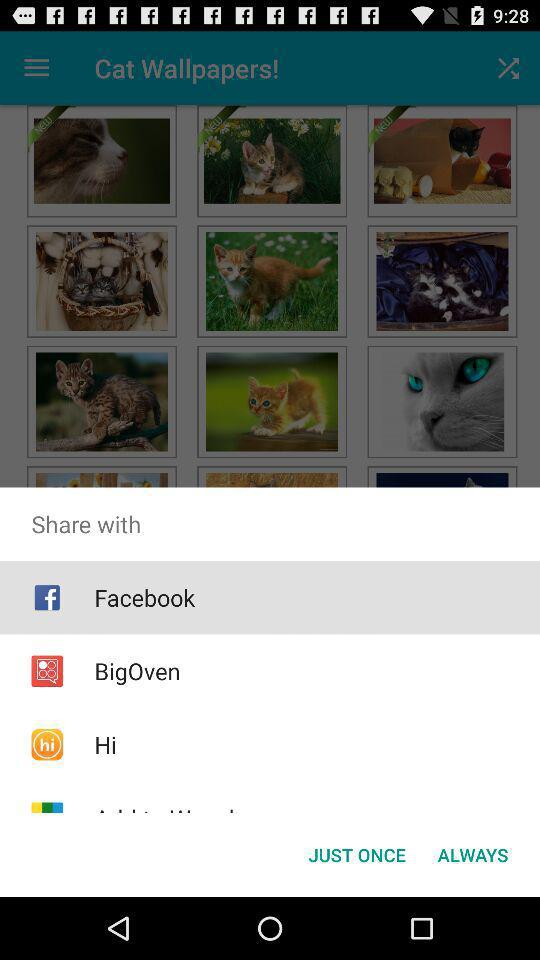Through which applications can the content be shared? The content can be shared through "Facebook", "BigOven" and "Hi". 